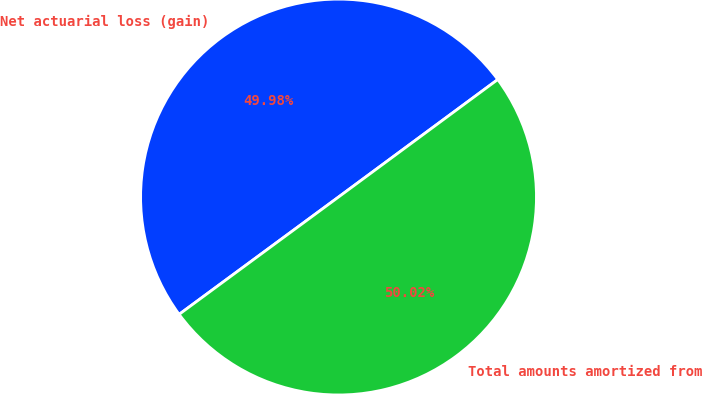Convert chart. <chart><loc_0><loc_0><loc_500><loc_500><pie_chart><fcel>Net actuarial loss (gain)<fcel>Total amounts amortized from<nl><fcel>49.98%<fcel>50.02%<nl></chart> 